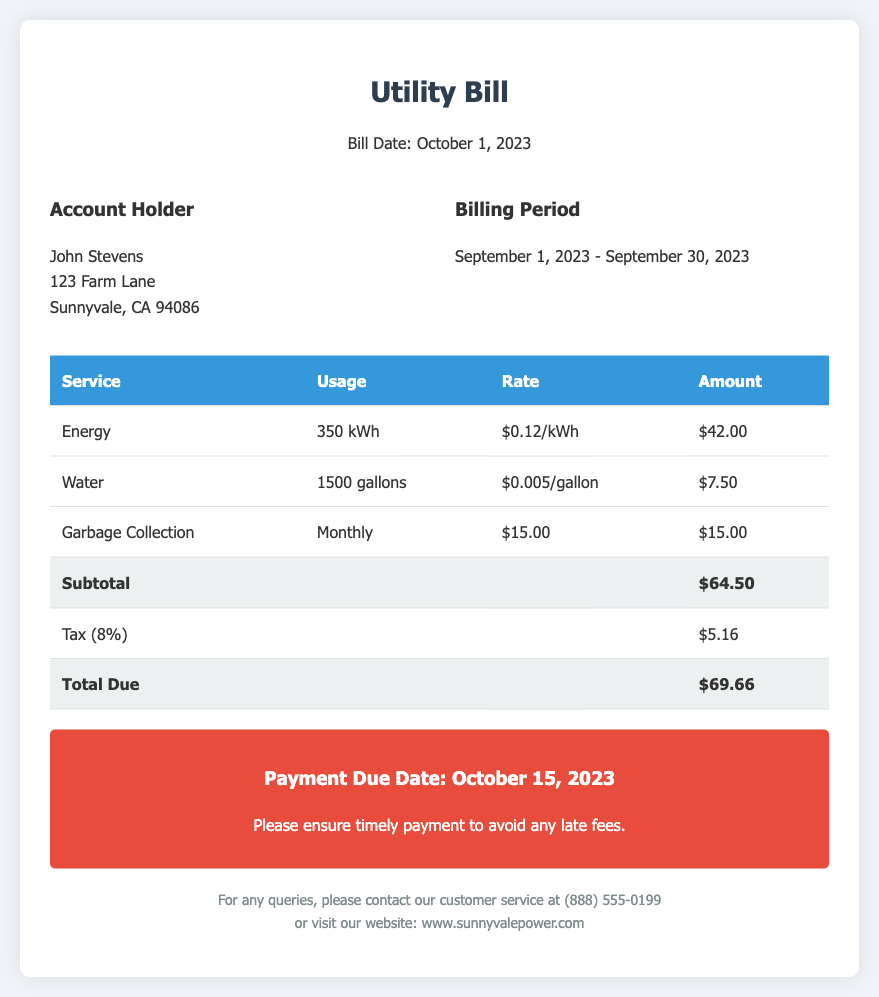What is the billing period? The billing period is specified in the document as the range of dates from September 1, 2023, to September 30, 2023.
Answer: September 1, 2023 - September 30, 2023 Who is the account holder? The account holder's name is mentioned in the document as John Stevens.
Answer: John Stevens What is the amount due for water usage? The document specifies the water usage amount as $7.50.
Answer: $7.50 What is the tax rate applied to the bill? The tax rate mentioned in the document is 8%.
Answer: 8% What is the total amount due? The total amount due at the end of the bill is detailed as $69.66.
Answer: $69.66 When is the payment due date? The due date for payment is stated as October 15, 2023.
Answer: October 15, 2023 How much energy was used? The energy usage recorded in the document is 350 kWh.
Answer: 350 kWh What service has a fixed monthly fee? The document indicates Garbage Collection has a fixed monthly fee of $15.00.
Answer: Garbage Collection What is the subtotal before tax? The subtotal before tax is summed up in the document as $64.50.
Answer: $64.50 